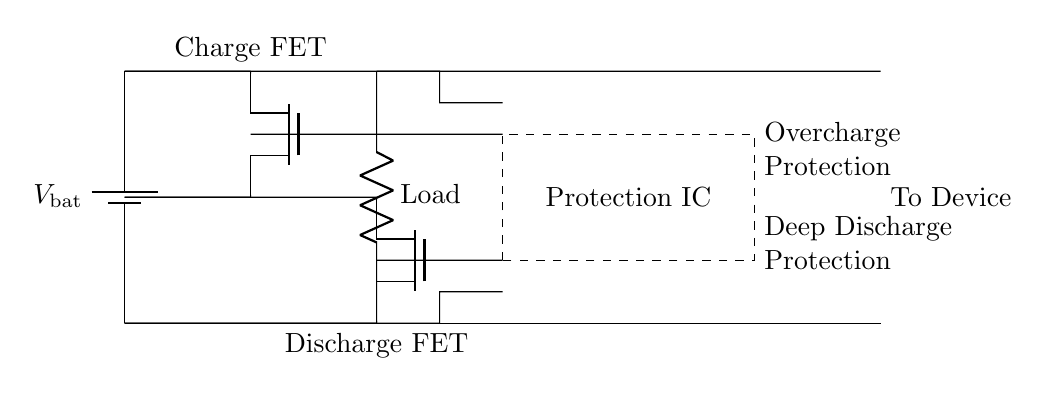What is the function of the charge MOSFET? The charge MOSFET manages the connection between the battery and the load during charging, allowing current to flow from the battery to the load when charging.
Answer: Charging What does the dashed rectangle represent? The dashed rectangle in the circuit signifies the Protection IC, which is responsible for overcharge and deep discharge protection mechanisms for the battery.
Answer: Protection IC How many main protection functions are indicated? The diagram indicates two main protection functions - overcharge protection and deep discharge protection.
Answer: Two What type of MOSFET is used for discharging? The MOSFET used for discharging is a Tnmos, as designated in the circuit diagram.
Answer: Tnmos What connects the load to the output? The connections from the discharge MOSFET to the load provide the pathway for current to the output, which leads to the device.
Answer: Discharge MOSFET Why is the protection IC important in this circuit? The protection IC is crucial as it safeguards the battery from dangerous conditions such as overcharging and excessive discharge, which can lead to battery failure or damage.
Answer: Safeguarding 